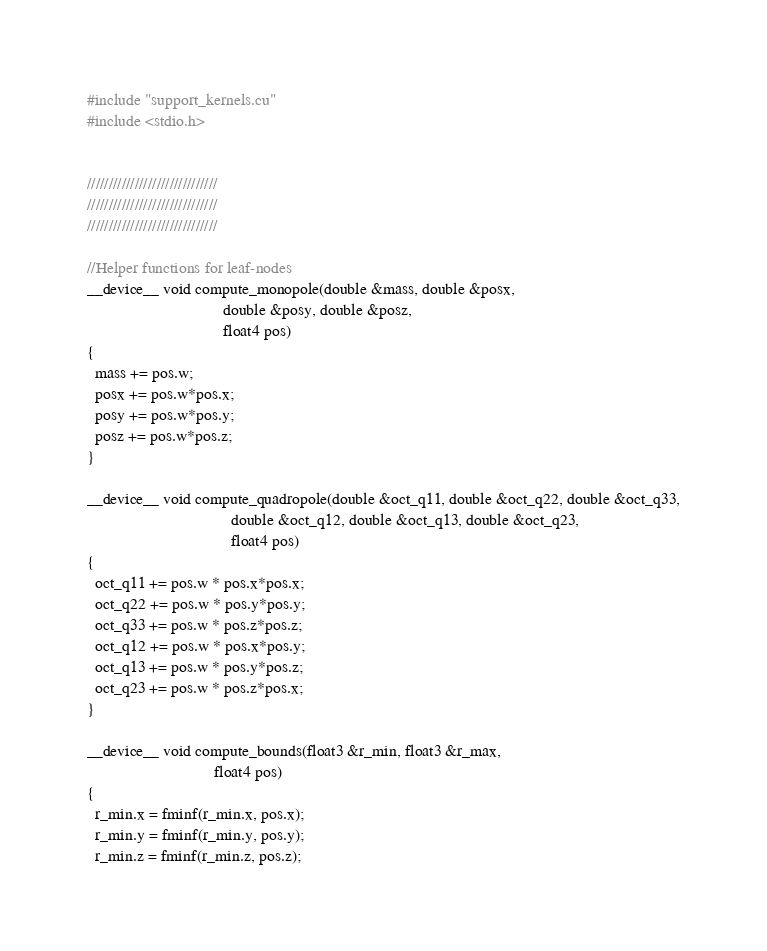Convert code to text. <code><loc_0><loc_0><loc_500><loc_500><_Cuda_>#include "support_kernels.cu"
#include <stdio.h>


//////////////////////////////
//////////////////////////////
//////////////////////////////

//Helper functions for leaf-nodes
__device__ void compute_monopole(double &mass, double &posx,
                                 double &posy, double &posz,
                                 float4 pos)
{
  mass += pos.w;
  posx += pos.w*pos.x;
  posy += pos.w*pos.y;
  posz += pos.w*pos.z;
}

__device__ void compute_quadropole(double &oct_q11, double &oct_q22, double &oct_q33,
                                   double &oct_q12, double &oct_q13, double &oct_q23,
                                   float4 pos)
{
  oct_q11 += pos.w * pos.x*pos.x;
  oct_q22 += pos.w * pos.y*pos.y;
  oct_q33 += pos.w * pos.z*pos.z;
  oct_q12 += pos.w * pos.x*pos.y;
  oct_q13 += pos.w * pos.y*pos.z;
  oct_q23 += pos.w * pos.z*pos.x;
}

__device__ void compute_bounds(float3 &r_min, float3 &r_max,
                               float4 pos)
{
  r_min.x = fminf(r_min.x, pos.x);
  r_min.y = fminf(r_min.y, pos.y);
  r_min.z = fminf(r_min.z, pos.z);
</code> 